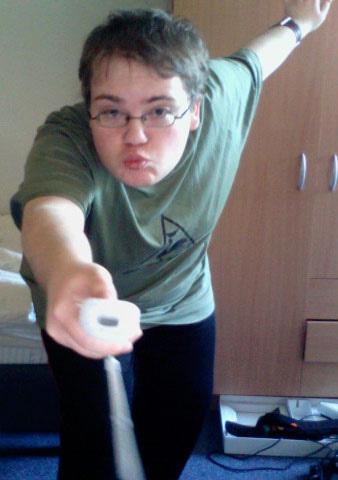Describe the objects in this image and their specific colors. I can see people in gray, black, and lightgray tones, remote in gray, white, and darkgray tones, and clock in gray, lightgray, and darkgray tones in this image. 